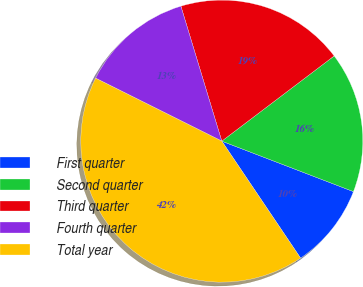Convert chart to OTSL. <chart><loc_0><loc_0><loc_500><loc_500><pie_chart><fcel>First quarter<fcel>Second quarter<fcel>Third quarter<fcel>Fourth quarter<fcel>Total year<nl><fcel>9.74%<fcel>16.15%<fcel>19.36%<fcel>12.95%<fcel>41.8%<nl></chart> 